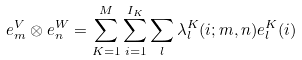<formula> <loc_0><loc_0><loc_500><loc_500>e _ { m } ^ { V } \otimes e _ { n } ^ { W } = \sum _ { K = 1 } ^ { M } \sum _ { i = 1 } ^ { I _ { K } } \sum _ { l } \lambda _ { l } ^ { K } ( i ; m , n ) e _ { l } ^ { K } ( i )</formula> 